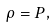Convert formula to latex. <formula><loc_0><loc_0><loc_500><loc_500>\rho = P ,</formula> 